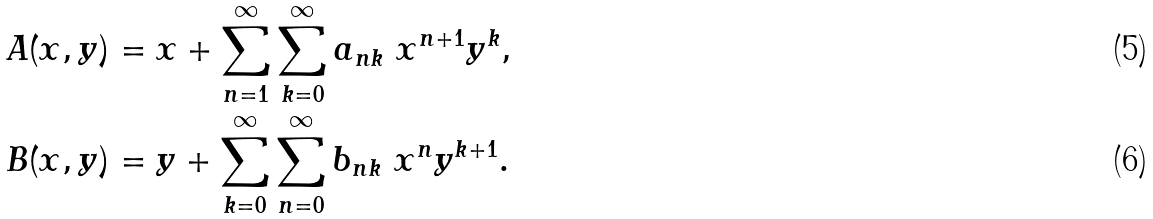<formula> <loc_0><loc_0><loc_500><loc_500>A ( x , y ) & = x + \sum _ { n = 1 } ^ { \infty } \sum _ { k = 0 } ^ { \infty } a _ { n k } \ x ^ { n + 1 } y ^ { k } , \\ B ( x , y ) & = y + \sum _ { k = 0 } ^ { \infty } \sum _ { n = 0 } ^ { \infty } b _ { n k } \ x ^ { n } y ^ { k + 1 } .</formula> 